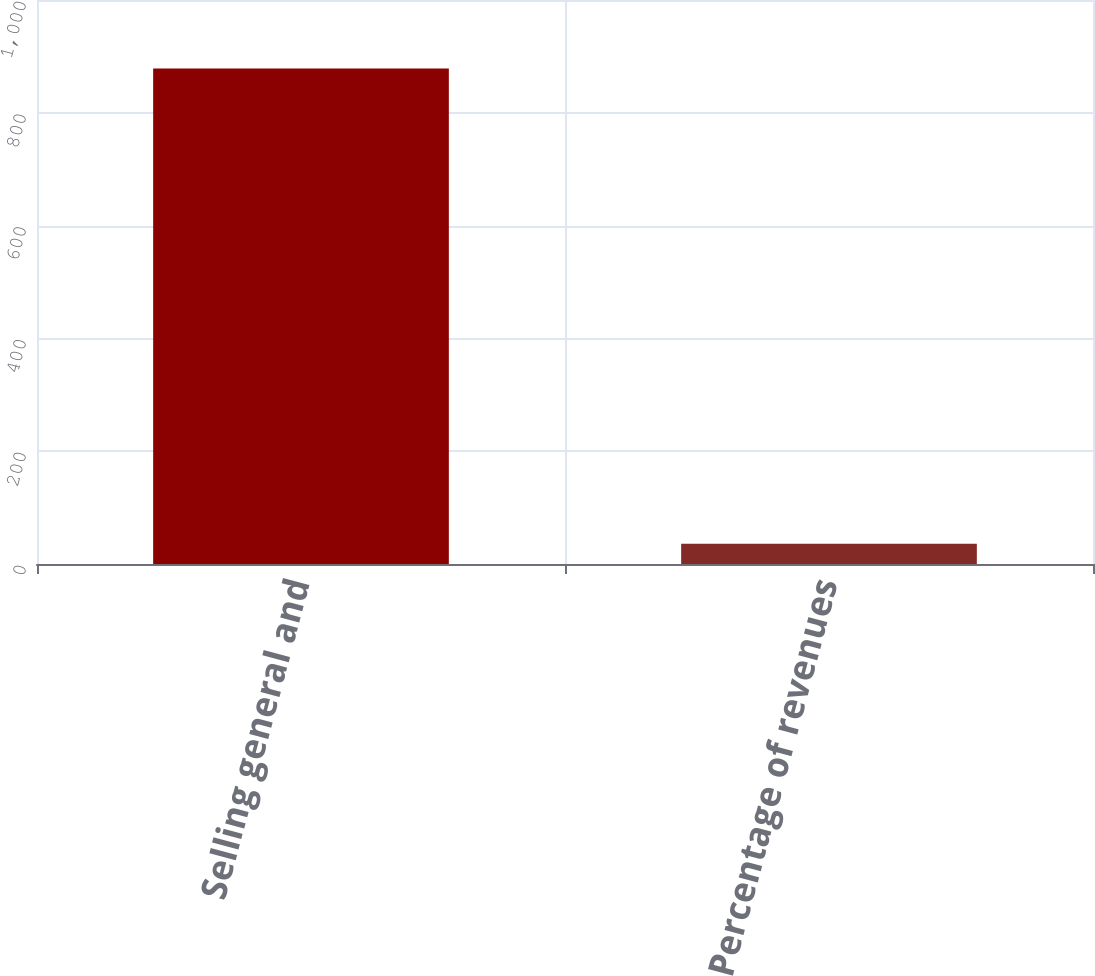Convert chart. <chart><loc_0><loc_0><loc_500><loc_500><bar_chart><fcel>Selling general and<fcel>Percentage of revenues<nl><fcel>878.7<fcel>35.9<nl></chart> 